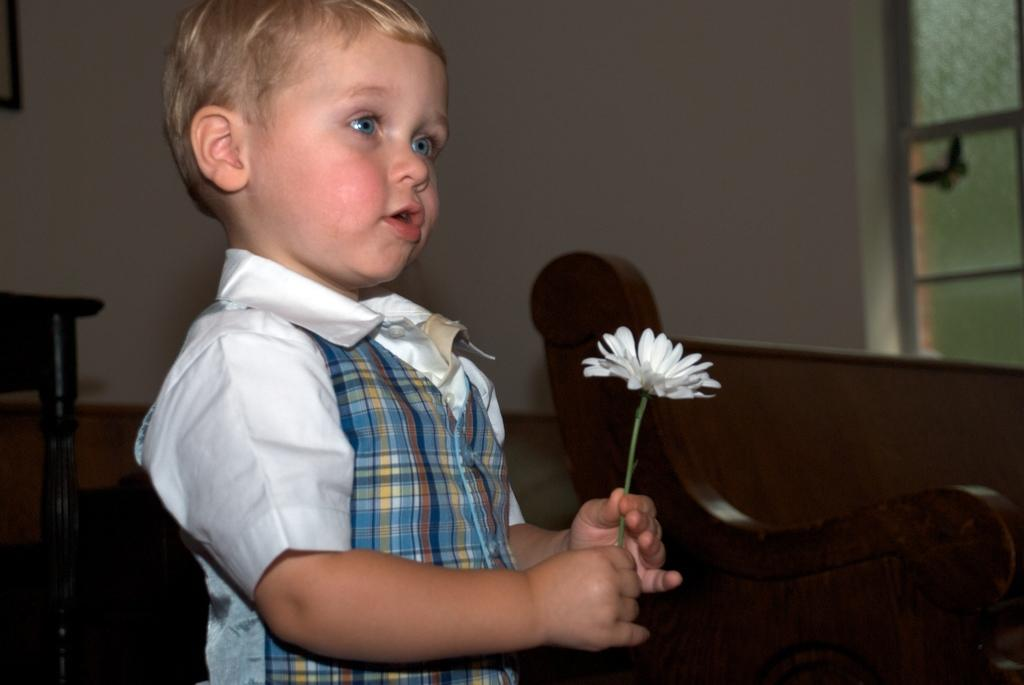Who is the main subject in the image? There is a boy in the image. What is the boy doing in the image? The boy is catching a flower in the image. What can be seen in the background of the image? There is a bench, a window, and a wall in the background of the image. How many grapes can be seen in the boy's eye in the image? There are no grapes present in the image, and the boy's eye cannot be seen in the image. 